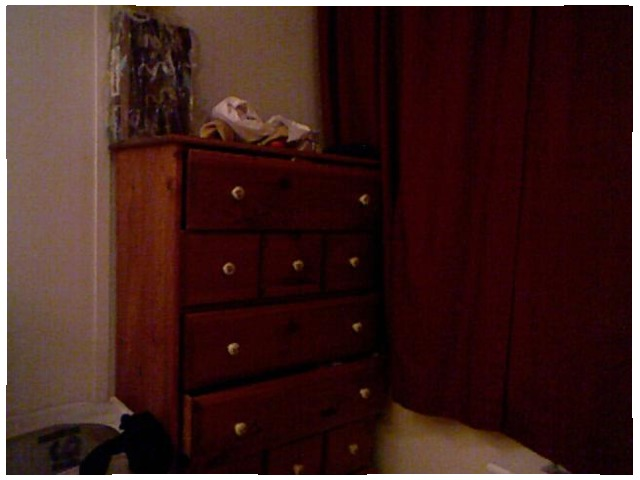<image>
Is there a cloth on the cupboard? Yes. Looking at the image, I can see the cloth is positioned on top of the cupboard, with the cupboard providing support. Is the dresser in the curtain? No. The dresser is not contained within the curtain. These objects have a different spatial relationship. 